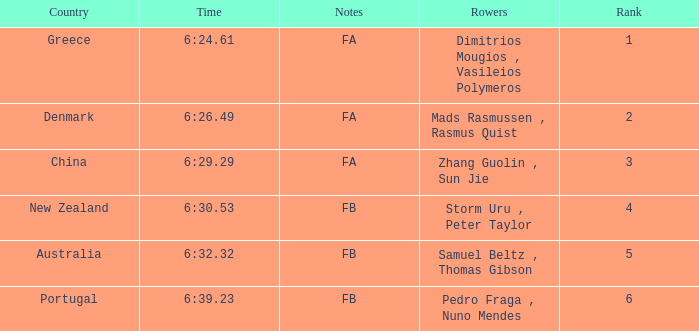What are the appellations of the rowers whose duration was 6:2 Dimitrios Mougios , Vasileios Polymeros. 